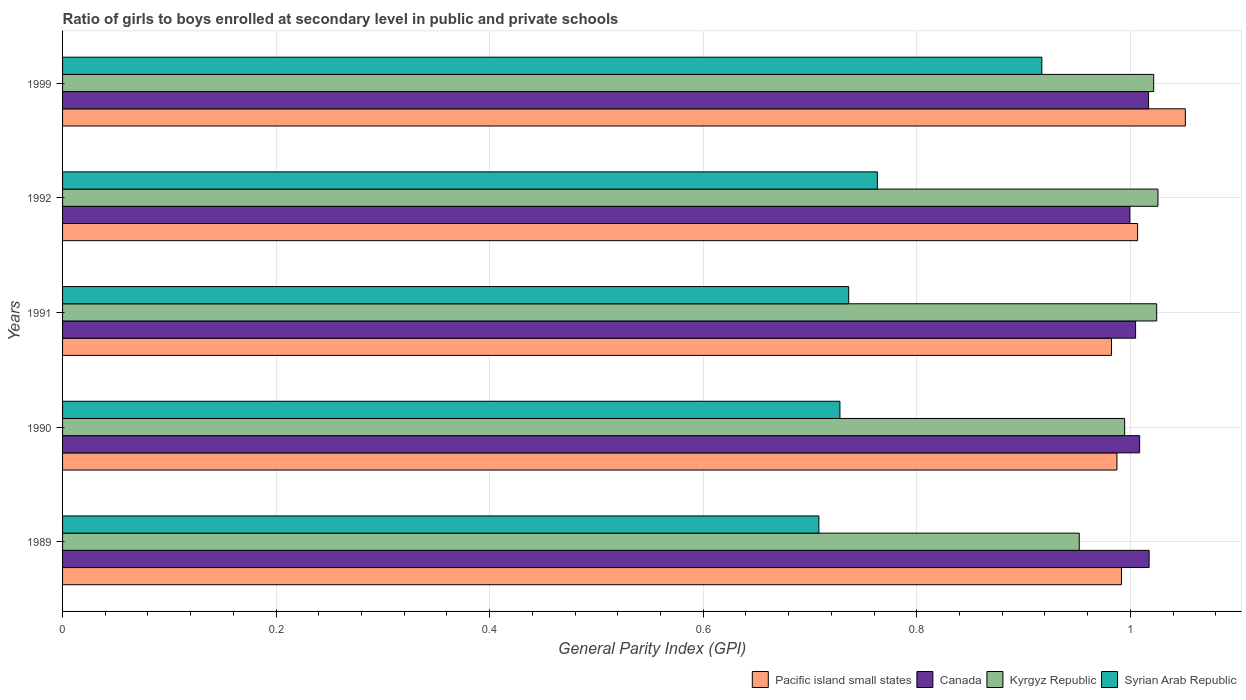How many different coloured bars are there?
Make the answer very short. 4. How many groups of bars are there?
Ensure brevity in your answer.  5. Are the number of bars per tick equal to the number of legend labels?
Your answer should be compact. Yes. How many bars are there on the 5th tick from the top?
Your answer should be compact. 4. How many bars are there on the 2nd tick from the bottom?
Provide a short and direct response. 4. What is the label of the 4th group of bars from the top?
Keep it short and to the point. 1990. In how many cases, is the number of bars for a given year not equal to the number of legend labels?
Your response must be concise. 0. What is the general parity index in Kyrgyz Republic in 1992?
Keep it short and to the point. 1.03. Across all years, what is the maximum general parity index in Kyrgyz Republic?
Keep it short and to the point. 1.03. Across all years, what is the minimum general parity index in Kyrgyz Republic?
Keep it short and to the point. 0.95. In which year was the general parity index in Pacific island small states minimum?
Provide a short and direct response. 1991. What is the total general parity index in Kyrgyz Republic in the graph?
Give a very brief answer. 5.02. What is the difference between the general parity index in Kyrgyz Republic in 1991 and that in 1992?
Ensure brevity in your answer.  -0. What is the difference between the general parity index in Kyrgyz Republic in 1990 and the general parity index in Syrian Arab Republic in 1999?
Provide a short and direct response. 0.08. What is the average general parity index in Canada per year?
Your answer should be compact. 1.01. In the year 1989, what is the difference between the general parity index in Pacific island small states and general parity index in Syrian Arab Republic?
Your response must be concise. 0.28. In how many years, is the general parity index in Canada greater than 0.28 ?
Make the answer very short. 5. What is the ratio of the general parity index in Syrian Arab Republic in 1989 to that in 1992?
Provide a short and direct response. 0.93. Is the difference between the general parity index in Pacific island small states in 1989 and 1992 greater than the difference between the general parity index in Syrian Arab Republic in 1989 and 1992?
Offer a terse response. Yes. What is the difference between the highest and the second highest general parity index in Pacific island small states?
Your response must be concise. 0.04. What is the difference between the highest and the lowest general parity index in Kyrgyz Republic?
Keep it short and to the point. 0.07. Is the sum of the general parity index in Syrian Arab Republic in 1992 and 1999 greater than the maximum general parity index in Kyrgyz Republic across all years?
Your response must be concise. Yes. Is it the case that in every year, the sum of the general parity index in Canada and general parity index in Pacific island small states is greater than the sum of general parity index in Syrian Arab Republic and general parity index in Kyrgyz Republic?
Your answer should be very brief. Yes. What does the 1st bar from the top in 1990 represents?
Ensure brevity in your answer.  Syrian Arab Republic. What does the 3rd bar from the bottom in 1990 represents?
Offer a very short reply. Kyrgyz Republic. How many bars are there?
Give a very brief answer. 20. How are the legend labels stacked?
Your response must be concise. Horizontal. What is the title of the graph?
Provide a short and direct response. Ratio of girls to boys enrolled at secondary level in public and private schools. Does "Least developed countries" appear as one of the legend labels in the graph?
Your answer should be compact. No. What is the label or title of the X-axis?
Provide a short and direct response. General Parity Index (GPI). What is the General Parity Index (GPI) in Pacific island small states in 1989?
Make the answer very short. 0.99. What is the General Parity Index (GPI) of Canada in 1989?
Keep it short and to the point. 1.02. What is the General Parity Index (GPI) of Kyrgyz Republic in 1989?
Give a very brief answer. 0.95. What is the General Parity Index (GPI) of Syrian Arab Republic in 1989?
Make the answer very short. 0.71. What is the General Parity Index (GPI) of Pacific island small states in 1990?
Make the answer very short. 0.99. What is the General Parity Index (GPI) in Canada in 1990?
Provide a succinct answer. 1.01. What is the General Parity Index (GPI) of Kyrgyz Republic in 1990?
Provide a short and direct response. 0.99. What is the General Parity Index (GPI) of Syrian Arab Republic in 1990?
Your response must be concise. 0.73. What is the General Parity Index (GPI) of Pacific island small states in 1991?
Ensure brevity in your answer.  0.98. What is the General Parity Index (GPI) in Canada in 1991?
Make the answer very short. 1. What is the General Parity Index (GPI) of Kyrgyz Republic in 1991?
Your response must be concise. 1.02. What is the General Parity Index (GPI) in Syrian Arab Republic in 1991?
Offer a very short reply. 0.74. What is the General Parity Index (GPI) in Pacific island small states in 1992?
Provide a short and direct response. 1.01. What is the General Parity Index (GPI) of Canada in 1992?
Provide a succinct answer. 1. What is the General Parity Index (GPI) in Kyrgyz Republic in 1992?
Your answer should be very brief. 1.03. What is the General Parity Index (GPI) of Syrian Arab Republic in 1992?
Ensure brevity in your answer.  0.76. What is the General Parity Index (GPI) of Pacific island small states in 1999?
Ensure brevity in your answer.  1.05. What is the General Parity Index (GPI) in Canada in 1999?
Provide a succinct answer. 1.02. What is the General Parity Index (GPI) of Kyrgyz Republic in 1999?
Keep it short and to the point. 1.02. What is the General Parity Index (GPI) in Syrian Arab Republic in 1999?
Your response must be concise. 0.92. Across all years, what is the maximum General Parity Index (GPI) of Pacific island small states?
Your answer should be compact. 1.05. Across all years, what is the maximum General Parity Index (GPI) in Canada?
Your answer should be very brief. 1.02. Across all years, what is the maximum General Parity Index (GPI) in Kyrgyz Republic?
Provide a short and direct response. 1.03. Across all years, what is the maximum General Parity Index (GPI) of Syrian Arab Republic?
Give a very brief answer. 0.92. Across all years, what is the minimum General Parity Index (GPI) of Pacific island small states?
Offer a very short reply. 0.98. Across all years, what is the minimum General Parity Index (GPI) in Canada?
Your response must be concise. 1. Across all years, what is the minimum General Parity Index (GPI) of Kyrgyz Republic?
Provide a succinct answer. 0.95. Across all years, what is the minimum General Parity Index (GPI) of Syrian Arab Republic?
Your response must be concise. 0.71. What is the total General Parity Index (GPI) in Pacific island small states in the graph?
Ensure brevity in your answer.  5.02. What is the total General Parity Index (GPI) of Canada in the graph?
Your answer should be compact. 5.05. What is the total General Parity Index (GPI) of Kyrgyz Republic in the graph?
Ensure brevity in your answer.  5.02. What is the total General Parity Index (GPI) in Syrian Arab Republic in the graph?
Offer a very short reply. 3.85. What is the difference between the General Parity Index (GPI) in Pacific island small states in 1989 and that in 1990?
Provide a succinct answer. 0. What is the difference between the General Parity Index (GPI) in Canada in 1989 and that in 1990?
Your answer should be compact. 0.01. What is the difference between the General Parity Index (GPI) of Kyrgyz Republic in 1989 and that in 1990?
Your answer should be compact. -0.04. What is the difference between the General Parity Index (GPI) of Syrian Arab Republic in 1989 and that in 1990?
Provide a succinct answer. -0.02. What is the difference between the General Parity Index (GPI) of Pacific island small states in 1989 and that in 1991?
Your response must be concise. 0.01. What is the difference between the General Parity Index (GPI) in Canada in 1989 and that in 1991?
Keep it short and to the point. 0.01. What is the difference between the General Parity Index (GPI) of Kyrgyz Republic in 1989 and that in 1991?
Ensure brevity in your answer.  -0.07. What is the difference between the General Parity Index (GPI) of Syrian Arab Republic in 1989 and that in 1991?
Your response must be concise. -0.03. What is the difference between the General Parity Index (GPI) of Pacific island small states in 1989 and that in 1992?
Your answer should be compact. -0.02. What is the difference between the General Parity Index (GPI) in Canada in 1989 and that in 1992?
Your answer should be compact. 0.02. What is the difference between the General Parity Index (GPI) in Kyrgyz Republic in 1989 and that in 1992?
Offer a terse response. -0.07. What is the difference between the General Parity Index (GPI) in Syrian Arab Republic in 1989 and that in 1992?
Provide a short and direct response. -0.05. What is the difference between the General Parity Index (GPI) in Pacific island small states in 1989 and that in 1999?
Give a very brief answer. -0.06. What is the difference between the General Parity Index (GPI) in Canada in 1989 and that in 1999?
Your answer should be very brief. 0. What is the difference between the General Parity Index (GPI) of Kyrgyz Republic in 1989 and that in 1999?
Your answer should be very brief. -0.07. What is the difference between the General Parity Index (GPI) in Syrian Arab Republic in 1989 and that in 1999?
Give a very brief answer. -0.21. What is the difference between the General Parity Index (GPI) of Pacific island small states in 1990 and that in 1991?
Your response must be concise. 0.01. What is the difference between the General Parity Index (GPI) in Canada in 1990 and that in 1991?
Ensure brevity in your answer.  0. What is the difference between the General Parity Index (GPI) in Kyrgyz Republic in 1990 and that in 1991?
Provide a short and direct response. -0.03. What is the difference between the General Parity Index (GPI) in Syrian Arab Republic in 1990 and that in 1991?
Your answer should be very brief. -0.01. What is the difference between the General Parity Index (GPI) of Pacific island small states in 1990 and that in 1992?
Your response must be concise. -0.02. What is the difference between the General Parity Index (GPI) in Canada in 1990 and that in 1992?
Your answer should be very brief. 0.01. What is the difference between the General Parity Index (GPI) of Kyrgyz Republic in 1990 and that in 1992?
Provide a short and direct response. -0.03. What is the difference between the General Parity Index (GPI) of Syrian Arab Republic in 1990 and that in 1992?
Give a very brief answer. -0.04. What is the difference between the General Parity Index (GPI) of Pacific island small states in 1990 and that in 1999?
Your response must be concise. -0.06. What is the difference between the General Parity Index (GPI) in Canada in 1990 and that in 1999?
Your answer should be very brief. -0.01. What is the difference between the General Parity Index (GPI) in Kyrgyz Republic in 1990 and that in 1999?
Make the answer very short. -0.03. What is the difference between the General Parity Index (GPI) in Syrian Arab Republic in 1990 and that in 1999?
Give a very brief answer. -0.19. What is the difference between the General Parity Index (GPI) in Pacific island small states in 1991 and that in 1992?
Keep it short and to the point. -0.02. What is the difference between the General Parity Index (GPI) of Canada in 1991 and that in 1992?
Make the answer very short. 0.01. What is the difference between the General Parity Index (GPI) of Kyrgyz Republic in 1991 and that in 1992?
Offer a very short reply. -0. What is the difference between the General Parity Index (GPI) in Syrian Arab Republic in 1991 and that in 1992?
Your answer should be compact. -0.03. What is the difference between the General Parity Index (GPI) of Pacific island small states in 1991 and that in 1999?
Your answer should be compact. -0.07. What is the difference between the General Parity Index (GPI) in Canada in 1991 and that in 1999?
Provide a short and direct response. -0.01. What is the difference between the General Parity Index (GPI) of Kyrgyz Republic in 1991 and that in 1999?
Offer a terse response. 0. What is the difference between the General Parity Index (GPI) of Syrian Arab Republic in 1991 and that in 1999?
Your answer should be compact. -0.18. What is the difference between the General Parity Index (GPI) in Pacific island small states in 1992 and that in 1999?
Make the answer very short. -0.04. What is the difference between the General Parity Index (GPI) of Canada in 1992 and that in 1999?
Provide a short and direct response. -0.02. What is the difference between the General Parity Index (GPI) of Kyrgyz Republic in 1992 and that in 1999?
Offer a very short reply. 0. What is the difference between the General Parity Index (GPI) of Syrian Arab Republic in 1992 and that in 1999?
Make the answer very short. -0.15. What is the difference between the General Parity Index (GPI) of Pacific island small states in 1989 and the General Parity Index (GPI) of Canada in 1990?
Give a very brief answer. -0.02. What is the difference between the General Parity Index (GPI) in Pacific island small states in 1989 and the General Parity Index (GPI) in Kyrgyz Republic in 1990?
Keep it short and to the point. -0. What is the difference between the General Parity Index (GPI) of Pacific island small states in 1989 and the General Parity Index (GPI) of Syrian Arab Republic in 1990?
Your answer should be compact. 0.26. What is the difference between the General Parity Index (GPI) in Canada in 1989 and the General Parity Index (GPI) in Kyrgyz Republic in 1990?
Offer a very short reply. 0.02. What is the difference between the General Parity Index (GPI) in Canada in 1989 and the General Parity Index (GPI) in Syrian Arab Republic in 1990?
Give a very brief answer. 0.29. What is the difference between the General Parity Index (GPI) of Kyrgyz Republic in 1989 and the General Parity Index (GPI) of Syrian Arab Republic in 1990?
Provide a short and direct response. 0.22. What is the difference between the General Parity Index (GPI) in Pacific island small states in 1989 and the General Parity Index (GPI) in Canada in 1991?
Ensure brevity in your answer.  -0.01. What is the difference between the General Parity Index (GPI) of Pacific island small states in 1989 and the General Parity Index (GPI) of Kyrgyz Republic in 1991?
Provide a succinct answer. -0.03. What is the difference between the General Parity Index (GPI) in Pacific island small states in 1989 and the General Parity Index (GPI) in Syrian Arab Republic in 1991?
Provide a short and direct response. 0.26. What is the difference between the General Parity Index (GPI) in Canada in 1989 and the General Parity Index (GPI) in Kyrgyz Republic in 1991?
Provide a short and direct response. -0.01. What is the difference between the General Parity Index (GPI) of Canada in 1989 and the General Parity Index (GPI) of Syrian Arab Republic in 1991?
Keep it short and to the point. 0.28. What is the difference between the General Parity Index (GPI) of Kyrgyz Republic in 1989 and the General Parity Index (GPI) of Syrian Arab Republic in 1991?
Offer a terse response. 0.22. What is the difference between the General Parity Index (GPI) of Pacific island small states in 1989 and the General Parity Index (GPI) of Canada in 1992?
Ensure brevity in your answer.  -0.01. What is the difference between the General Parity Index (GPI) of Pacific island small states in 1989 and the General Parity Index (GPI) of Kyrgyz Republic in 1992?
Keep it short and to the point. -0.03. What is the difference between the General Parity Index (GPI) of Pacific island small states in 1989 and the General Parity Index (GPI) of Syrian Arab Republic in 1992?
Offer a very short reply. 0.23. What is the difference between the General Parity Index (GPI) of Canada in 1989 and the General Parity Index (GPI) of Kyrgyz Republic in 1992?
Keep it short and to the point. -0.01. What is the difference between the General Parity Index (GPI) of Canada in 1989 and the General Parity Index (GPI) of Syrian Arab Republic in 1992?
Give a very brief answer. 0.25. What is the difference between the General Parity Index (GPI) of Kyrgyz Republic in 1989 and the General Parity Index (GPI) of Syrian Arab Republic in 1992?
Your answer should be very brief. 0.19. What is the difference between the General Parity Index (GPI) in Pacific island small states in 1989 and the General Parity Index (GPI) in Canada in 1999?
Offer a very short reply. -0.03. What is the difference between the General Parity Index (GPI) in Pacific island small states in 1989 and the General Parity Index (GPI) in Kyrgyz Republic in 1999?
Your answer should be very brief. -0.03. What is the difference between the General Parity Index (GPI) of Pacific island small states in 1989 and the General Parity Index (GPI) of Syrian Arab Republic in 1999?
Make the answer very short. 0.07. What is the difference between the General Parity Index (GPI) of Canada in 1989 and the General Parity Index (GPI) of Kyrgyz Republic in 1999?
Your answer should be compact. -0. What is the difference between the General Parity Index (GPI) of Canada in 1989 and the General Parity Index (GPI) of Syrian Arab Republic in 1999?
Your answer should be very brief. 0.1. What is the difference between the General Parity Index (GPI) of Kyrgyz Republic in 1989 and the General Parity Index (GPI) of Syrian Arab Republic in 1999?
Provide a succinct answer. 0.04. What is the difference between the General Parity Index (GPI) in Pacific island small states in 1990 and the General Parity Index (GPI) in Canada in 1991?
Provide a short and direct response. -0.02. What is the difference between the General Parity Index (GPI) in Pacific island small states in 1990 and the General Parity Index (GPI) in Kyrgyz Republic in 1991?
Your answer should be very brief. -0.04. What is the difference between the General Parity Index (GPI) in Pacific island small states in 1990 and the General Parity Index (GPI) in Syrian Arab Republic in 1991?
Offer a very short reply. 0.25. What is the difference between the General Parity Index (GPI) of Canada in 1990 and the General Parity Index (GPI) of Kyrgyz Republic in 1991?
Your answer should be compact. -0.02. What is the difference between the General Parity Index (GPI) of Canada in 1990 and the General Parity Index (GPI) of Syrian Arab Republic in 1991?
Ensure brevity in your answer.  0.27. What is the difference between the General Parity Index (GPI) of Kyrgyz Republic in 1990 and the General Parity Index (GPI) of Syrian Arab Republic in 1991?
Make the answer very short. 0.26. What is the difference between the General Parity Index (GPI) of Pacific island small states in 1990 and the General Parity Index (GPI) of Canada in 1992?
Give a very brief answer. -0.01. What is the difference between the General Parity Index (GPI) in Pacific island small states in 1990 and the General Parity Index (GPI) in Kyrgyz Republic in 1992?
Provide a short and direct response. -0.04. What is the difference between the General Parity Index (GPI) in Pacific island small states in 1990 and the General Parity Index (GPI) in Syrian Arab Republic in 1992?
Ensure brevity in your answer.  0.22. What is the difference between the General Parity Index (GPI) in Canada in 1990 and the General Parity Index (GPI) in Kyrgyz Republic in 1992?
Offer a very short reply. -0.02. What is the difference between the General Parity Index (GPI) in Canada in 1990 and the General Parity Index (GPI) in Syrian Arab Republic in 1992?
Make the answer very short. 0.25. What is the difference between the General Parity Index (GPI) of Kyrgyz Republic in 1990 and the General Parity Index (GPI) of Syrian Arab Republic in 1992?
Your answer should be very brief. 0.23. What is the difference between the General Parity Index (GPI) of Pacific island small states in 1990 and the General Parity Index (GPI) of Canada in 1999?
Ensure brevity in your answer.  -0.03. What is the difference between the General Parity Index (GPI) of Pacific island small states in 1990 and the General Parity Index (GPI) of Kyrgyz Republic in 1999?
Provide a short and direct response. -0.03. What is the difference between the General Parity Index (GPI) of Pacific island small states in 1990 and the General Parity Index (GPI) of Syrian Arab Republic in 1999?
Your response must be concise. 0.07. What is the difference between the General Parity Index (GPI) in Canada in 1990 and the General Parity Index (GPI) in Kyrgyz Republic in 1999?
Your answer should be compact. -0.01. What is the difference between the General Parity Index (GPI) in Canada in 1990 and the General Parity Index (GPI) in Syrian Arab Republic in 1999?
Your answer should be very brief. 0.09. What is the difference between the General Parity Index (GPI) of Kyrgyz Republic in 1990 and the General Parity Index (GPI) of Syrian Arab Republic in 1999?
Your answer should be very brief. 0.08. What is the difference between the General Parity Index (GPI) of Pacific island small states in 1991 and the General Parity Index (GPI) of Canada in 1992?
Your answer should be very brief. -0.02. What is the difference between the General Parity Index (GPI) in Pacific island small states in 1991 and the General Parity Index (GPI) in Kyrgyz Republic in 1992?
Offer a very short reply. -0.04. What is the difference between the General Parity Index (GPI) in Pacific island small states in 1991 and the General Parity Index (GPI) in Syrian Arab Republic in 1992?
Make the answer very short. 0.22. What is the difference between the General Parity Index (GPI) of Canada in 1991 and the General Parity Index (GPI) of Kyrgyz Republic in 1992?
Provide a succinct answer. -0.02. What is the difference between the General Parity Index (GPI) in Canada in 1991 and the General Parity Index (GPI) in Syrian Arab Republic in 1992?
Make the answer very short. 0.24. What is the difference between the General Parity Index (GPI) of Kyrgyz Republic in 1991 and the General Parity Index (GPI) of Syrian Arab Republic in 1992?
Give a very brief answer. 0.26. What is the difference between the General Parity Index (GPI) in Pacific island small states in 1991 and the General Parity Index (GPI) in Canada in 1999?
Provide a short and direct response. -0.03. What is the difference between the General Parity Index (GPI) in Pacific island small states in 1991 and the General Parity Index (GPI) in Kyrgyz Republic in 1999?
Your answer should be very brief. -0.04. What is the difference between the General Parity Index (GPI) of Pacific island small states in 1991 and the General Parity Index (GPI) of Syrian Arab Republic in 1999?
Provide a succinct answer. 0.07. What is the difference between the General Parity Index (GPI) in Canada in 1991 and the General Parity Index (GPI) in Kyrgyz Republic in 1999?
Give a very brief answer. -0.02. What is the difference between the General Parity Index (GPI) in Canada in 1991 and the General Parity Index (GPI) in Syrian Arab Republic in 1999?
Your answer should be compact. 0.09. What is the difference between the General Parity Index (GPI) of Kyrgyz Republic in 1991 and the General Parity Index (GPI) of Syrian Arab Republic in 1999?
Ensure brevity in your answer.  0.11. What is the difference between the General Parity Index (GPI) of Pacific island small states in 1992 and the General Parity Index (GPI) of Canada in 1999?
Give a very brief answer. -0.01. What is the difference between the General Parity Index (GPI) of Pacific island small states in 1992 and the General Parity Index (GPI) of Kyrgyz Republic in 1999?
Your response must be concise. -0.02. What is the difference between the General Parity Index (GPI) of Pacific island small states in 1992 and the General Parity Index (GPI) of Syrian Arab Republic in 1999?
Your answer should be very brief. 0.09. What is the difference between the General Parity Index (GPI) in Canada in 1992 and the General Parity Index (GPI) in Kyrgyz Republic in 1999?
Your answer should be very brief. -0.02. What is the difference between the General Parity Index (GPI) of Canada in 1992 and the General Parity Index (GPI) of Syrian Arab Republic in 1999?
Provide a short and direct response. 0.08. What is the difference between the General Parity Index (GPI) in Kyrgyz Republic in 1992 and the General Parity Index (GPI) in Syrian Arab Republic in 1999?
Provide a succinct answer. 0.11. What is the average General Parity Index (GPI) of Canada per year?
Your answer should be compact. 1.01. What is the average General Parity Index (GPI) of Kyrgyz Republic per year?
Offer a terse response. 1. What is the average General Parity Index (GPI) of Syrian Arab Republic per year?
Keep it short and to the point. 0.77. In the year 1989, what is the difference between the General Parity Index (GPI) of Pacific island small states and General Parity Index (GPI) of Canada?
Provide a succinct answer. -0.03. In the year 1989, what is the difference between the General Parity Index (GPI) of Pacific island small states and General Parity Index (GPI) of Kyrgyz Republic?
Keep it short and to the point. 0.04. In the year 1989, what is the difference between the General Parity Index (GPI) in Pacific island small states and General Parity Index (GPI) in Syrian Arab Republic?
Your response must be concise. 0.28. In the year 1989, what is the difference between the General Parity Index (GPI) of Canada and General Parity Index (GPI) of Kyrgyz Republic?
Keep it short and to the point. 0.07. In the year 1989, what is the difference between the General Parity Index (GPI) of Canada and General Parity Index (GPI) of Syrian Arab Republic?
Give a very brief answer. 0.31. In the year 1989, what is the difference between the General Parity Index (GPI) of Kyrgyz Republic and General Parity Index (GPI) of Syrian Arab Republic?
Offer a very short reply. 0.24. In the year 1990, what is the difference between the General Parity Index (GPI) of Pacific island small states and General Parity Index (GPI) of Canada?
Your response must be concise. -0.02. In the year 1990, what is the difference between the General Parity Index (GPI) in Pacific island small states and General Parity Index (GPI) in Kyrgyz Republic?
Offer a terse response. -0.01. In the year 1990, what is the difference between the General Parity Index (GPI) in Pacific island small states and General Parity Index (GPI) in Syrian Arab Republic?
Ensure brevity in your answer.  0.26. In the year 1990, what is the difference between the General Parity Index (GPI) of Canada and General Parity Index (GPI) of Kyrgyz Republic?
Make the answer very short. 0.01. In the year 1990, what is the difference between the General Parity Index (GPI) of Canada and General Parity Index (GPI) of Syrian Arab Republic?
Your response must be concise. 0.28. In the year 1990, what is the difference between the General Parity Index (GPI) of Kyrgyz Republic and General Parity Index (GPI) of Syrian Arab Republic?
Your answer should be compact. 0.27. In the year 1991, what is the difference between the General Parity Index (GPI) in Pacific island small states and General Parity Index (GPI) in Canada?
Provide a short and direct response. -0.02. In the year 1991, what is the difference between the General Parity Index (GPI) in Pacific island small states and General Parity Index (GPI) in Kyrgyz Republic?
Your answer should be compact. -0.04. In the year 1991, what is the difference between the General Parity Index (GPI) in Pacific island small states and General Parity Index (GPI) in Syrian Arab Republic?
Ensure brevity in your answer.  0.25. In the year 1991, what is the difference between the General Parity Index (GPI) in Canada and General Parity Index (GPI) in Kyrgyz Republic?
Your answer should be compact. -0.02. In the year 1991, what is the difference between the General Parity Index (GPI) of Canada and General Parity Index (GPI) of Syrian Arab Republic?
Provide a succinct answer. 0.27. In the year 1991, what is the difference between the General Parity Index (GPI) of Kyrgyz Republic and General Parity Index (GPI) of Syrian Arab Republic?
Your answer should be very brief. 0.29. In the year 1992, what is the difference between the General Parity Index (GPI) in Pacific island small states and General Parity Index (GPI) in Canada?
Your answer should be compact. 0.01. In the year 1992, what is the difference between the General Parity Index (GPI) in Pacific island small states and General Parity Index (GPI) in Kyrgyz Republic?
Your response must be concise. -0.02. In the year 1992, what is the difference between the General Parity Index (GPI) in Pacific island small states and General Parity Index (GPI) in Syrian Arab Republic?
Offer a very short reply. 0.24. In the year 1992, what is the difference between the General Parity Index (GPI) in Canada and General Parity Index (GPI) in Kyrgyz Republic?
Your answer should be very brief. -0.03. In the year 1992, what is the difference between the General Parity Index (GPI) of Canada and General Parity Index (GPI) of Syrian Arab Republic?
Keep it short and to the point. 0.24. In the year 1992, what is the difference between the General Parity Index (GPI) in Kyrgyz Republic and General Parity Index (GPI) in Syrian Arab Republic?
Give a very brief answer. 0.26. In the year 1999, what is the difference between the General Parity Index (GPI) in Pacific island small states and General Parity Index (GPI) in Canada?
Offer a very short reply. 0.03. In the year 1999, what is the difference between the General Parity Index (GPI) in Pacific island small states and General Parity Index (GPI) in Kyrgyz Republic?
Ensure brevity in your answer.  0.03. In the year 1999, what is the difference between the General Parity Index (GPI) of Pacific island small states and General Parity Index (GPI) of Syrian Arab Republic?
Offer a terse response. 0.13. In the year 1999, what is the difference between the General Parity Index (GPI) of Canada and General Parity Index (GPI) of Kyrgyz Republic?
Offer a terse response. -0. In the year 1999, what is the difference between the General Parity Index (GPI) of Kyrgyz Republic and General Parity Index (GPI) of Syrian Arab Republic?
Give a very brief answer. 0.1. What is the ratio of the General Parity Index (GPI) of Pacific island small states in 1989 to that in 1990?
Offer a very short reply. 1. What is the ratio of the General Parity Index (GPI) of Canada in 1989 to that in 1990?
Offer a terse response. 1.01. What is the ratio of the General Parity Index (GPI) of Kyrgyz Republic in 1989 to that in 1990?
Your response must be concise. 0.96. What is the ratio of the General Parity Index (GPI) in Syrian Arab Republic in 1989 to that in 1990?
Offer a terse response. 0.97. What is the ratio of the General Parity Index (GPI) of Pacific island small states in 1989 to that in 1991?
Provide a succinct answer. 1.01. What is the ratio of the General Parity Index (GPI) of Canada in 1989 to that in 1991?
Provide a short and direct response. 1.01. What is the ratio of the General Parity Index (GPI) in Kyrgyz Republic in 1989 to that in 1991?
Make the answer very short. 0.93. What is the ratio of the General Parity Index (GPI) in Syrian Arab Republic in 1989 to that in 1991?
Keep it short and to the point. 0.96. What is the ratio of the General Parity Index (GPI) of Pacific island small states in 1989 to that in 1992?
Provide a succinct answer. 0.98. What is the ratio of the General Parity Index (GPI) in Canada in 1989 to that in 1992?
Provide a short and direct response. 1.02. What is the ratio of the General Parity Index (GPI) of Kyrgyz Republic in 1989 to that in 1992?
Keep it short and to the point. 0.93. What is the ratio of the General Parity Index (GPI) of Syrian Arab Republic in 1989 to that in 1992?
Give a very brief answer. 0.93. What is the ratio of the General Parity Index (GPI) of Pacific island small states in 1989 to that in 1999?
Provide a short and direct response. 0.94. What is the ratio of the General Parity Index (GPI) in Canada in 1989 to that in 1999?
Keep it short and to the point. 1. What is the ratio of the General Parity Index (GPI) in Kyrgyz Republic in 1989 to that in 1999?
Offer a very short reply. 0.93. What is the ratio of the General Parity Index (GPI) in Syrian Arab Republic in 1989 to that in 1999?
Provide a succinct answer. 0.77. What is the ratio of the General Parity Index (GPI) of Canada in 1990 to that in 1991?
Offer a very short reply. 1. What is the ratio of the General Parity Index (GPI) of Kyrgyz Republic in 1990 to that in 1991?
Provide a succinct answer. 0.97. What is the ratio of the General Parity Index (GPI) in Pacific island small states in 1990 to that in 1992?
Provide a succinct answer. 0.98. What is the ratio of the General Parity Index (GPI) of Canada in 1990 to that in 1992?
Offer a very short reply. 1.01. What is the ratio of the General Parity Index (GPI) in Kyrgyz Republic in 1990 to that in 1992?
Make the answer very short. 0.97. What is the ratio of the General Parity Index (GPI) of Syrian Arab Republic in 1990 to that in 1992?
Your answer should be very brief. 0.95. What is the ratio of the General Parity Index (GPI) of Pacific island small states in 1990 to that in 1999?
Provide a short and direct response. 0.94. What is the ratio of the General Parity Index (GPI) in Canada in 1990 to that in 1999?
Keep it short and to the point. 0.99. What is the ratio of the General Parity Index (GPI) in Kyrgyz Republic in 1990 to that in 1999?
Your answer should be very brief. 0.97. What is the ratio of the General Parity Index (GPI) of Syrian Arab Republic in 1990 to that in 1999?
Ensure brevity in your answer.  0.79. What is the ratio of the General Parity Index (GPI) in Pacific island small states in 1991 to that in 1992?
Keep it short and to the point. 0.98. What is the ratio of the General Parity Index (GPI) of Canada in 1991 to that in 1992?
Keep it short and to the point. 1.01. What is the ratio of the General Parity Index (GPI) of Syrian Arab Republic in 1991 to that in 1992?
Your response must be concise. 0.96. What is the ratio of the General Parity Index (GPI) of Pacific island small states in 1991 to that in 1999?
Make the answer very short. 0.93. What is the ratio of the General Parity Index (GPI) of Syrian Arab Republic in 1991 to that in 1999?
Ensure brevity in your answer.  0.8. What is the ratio of the General Parity Index (GPI) of Pacific island small states in 1992 to that in 1999?
Your response must be concise. 0.96. What is the ratio of the General Parity Index (GPI) in Canada in 1992 to that in 1999?
Keep it short and to the point. 0.98. What is the ratio of the General Parity Index (GPI) in Kyrgyz Republic in 1992 to that in 1999?
Keep it short and to the point. 1. What is the ratio of the General Parity Index (GPI) of Syrian Arab Republic in 1992 to that in 1999?
Your answer should be very brief. 0.83. What is the difference between the highest and the second highest General Parity Index (GPI) in Pacific island small states?
Keep it short and to the point. 0.04. What is the difference between the highest and the second highest General Parity Index (GPI) in Kyrgyz Republic?
Ensure brevity in your answer.  0. What is the difference between the highest and the second highest General Parity Index (GPI) of Syrian Arab Republic?
Your answer should be compact. 0.15. What is the difference between the highest and the lowest General Parity Index (GPI) of Pacific island small states?
Offer a very short reply. 0.07. What is the difference between the highest and the lowest General Parity Index (GPI) of Canada?
Make the answer very short. 0.02. What is the difference between the highest and the lowest General Parity Index (GPI) in Kyrgyz Republic?
Your response must be concise. 0.07. What is the difference between the highest and the lowest General Parity Index (GPI) in Syrian Arab Republic?
Offer a very short reply. 0.21. 